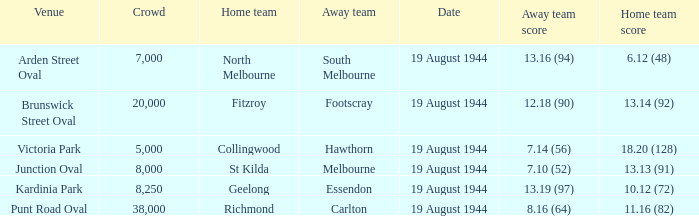What is Fitzroy's Home team score? 13.14 (92). 